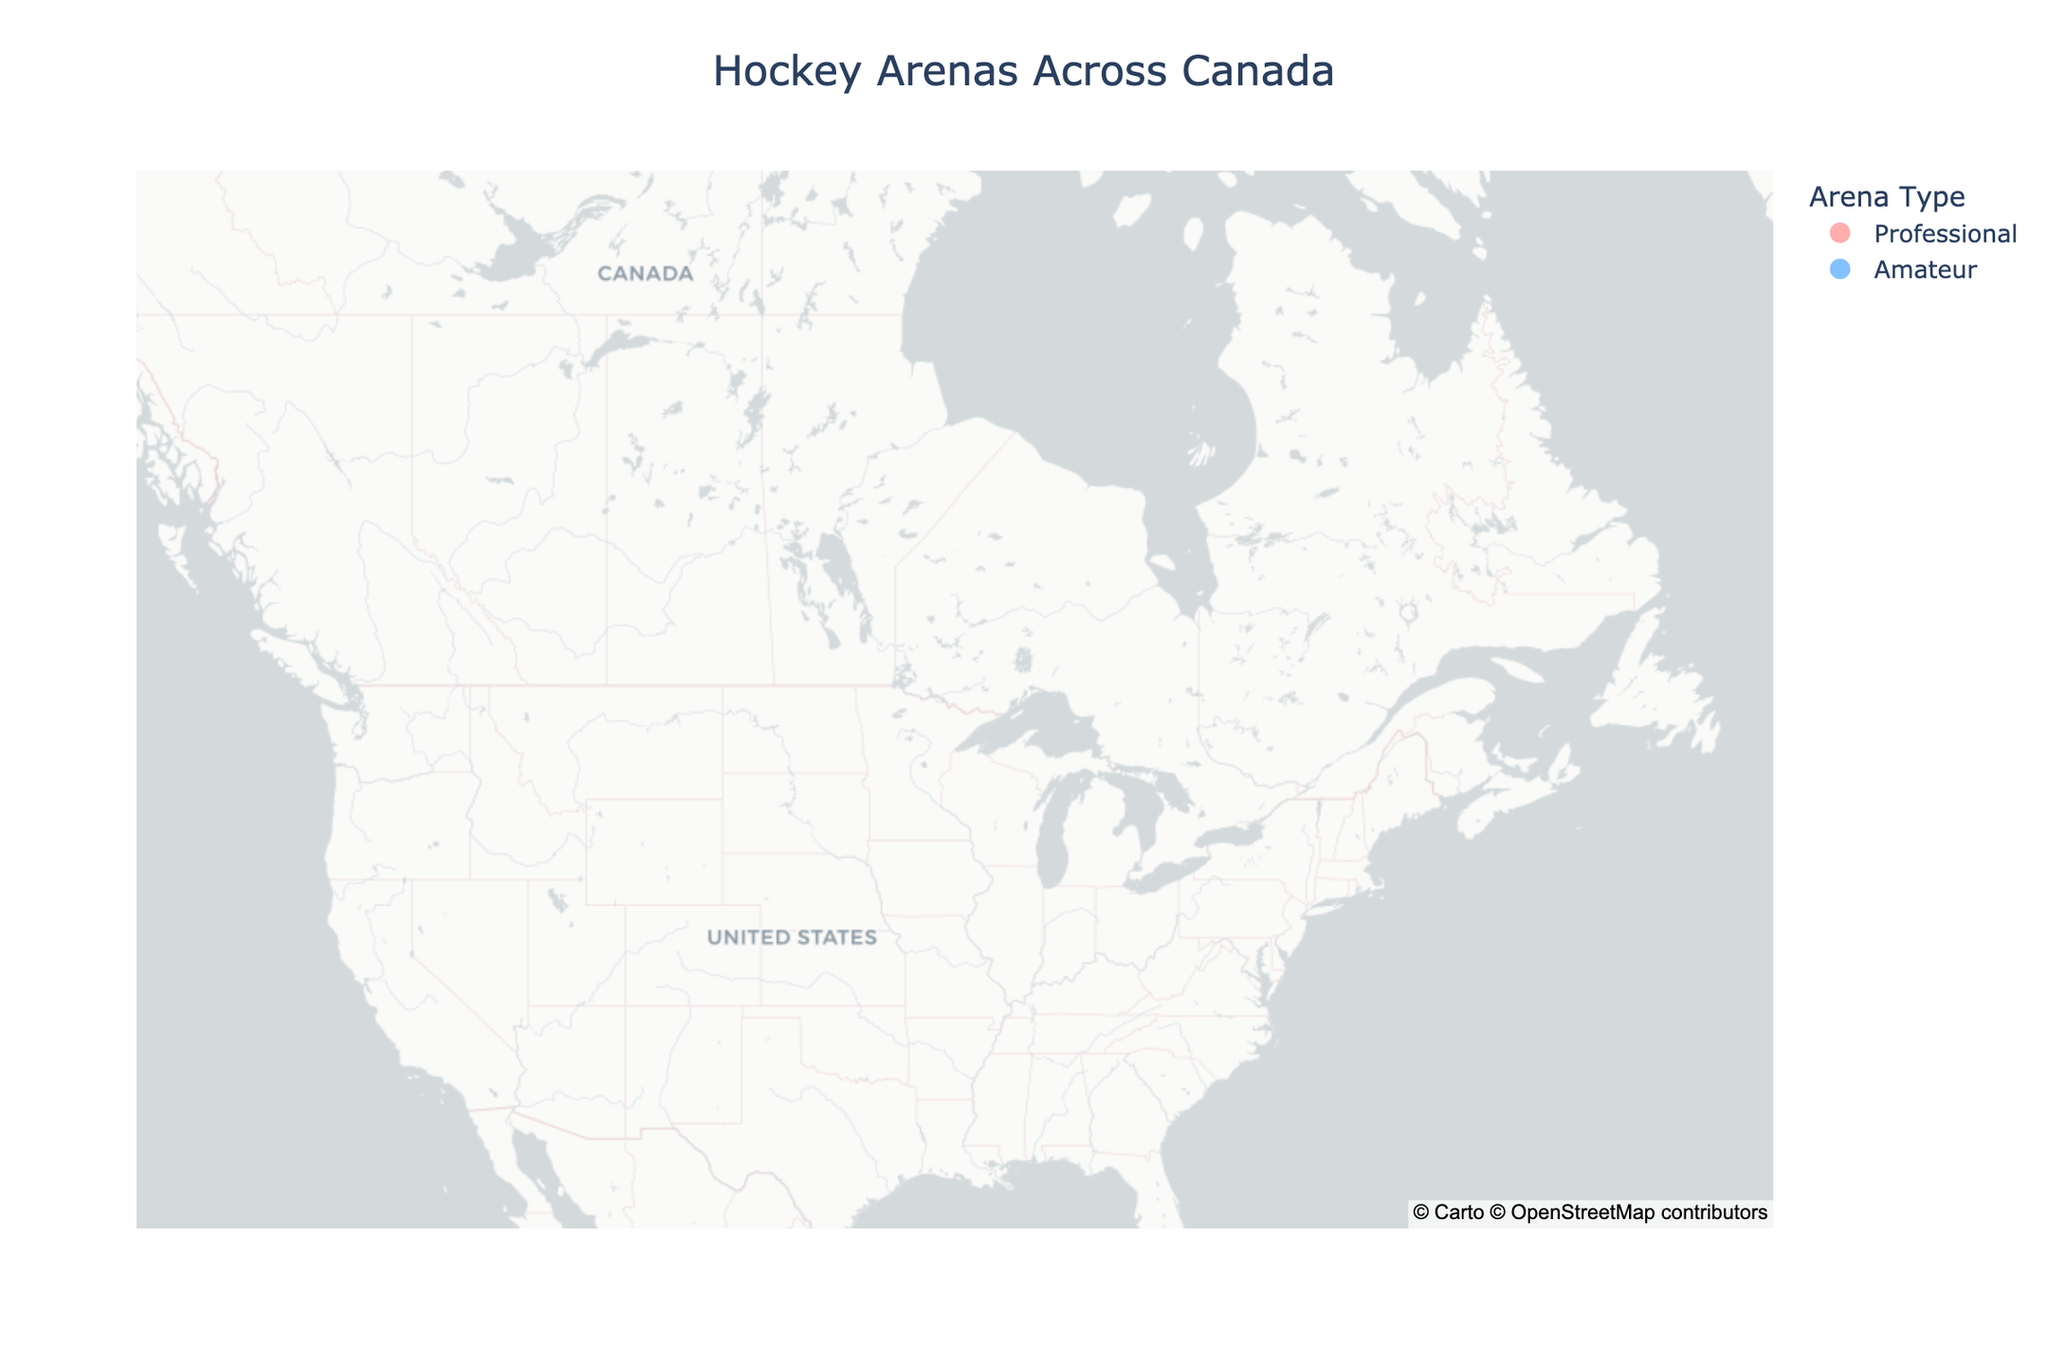Which city in Manitoba has an amateur hockey arena? By looking at Manitoba, we see that Brandon has an amateur arena named Westoba Place.
Answer: Brandon How many professional hockey arenas are in Ontario? By locating Ontario, we see there is one professional hockey arena, Scotiabank Arena in Toronto.
Answer: One Which province has both professional and amateur hockey arenas? By examining the provinces, Alberta is the one with both professional arena (Rogers Place in Edmonton) and amateur arena (Scotiabank Saddledome in Calgary).
Answer: Alberta Is there a professional hockey arena in Nova Scotia? By checking Nova Scotia, we see only an amateur arena, the Scotiabank Centre in Halifax, not a professional one.
Answer: No Which city has a hockey arena named Canada Life Centre? By inspecting the map, we see the Canada Life Centre is located in Winnipeg, Manitoba.
Answer: Winnipeg How many amateur hockey arenas are located in British Columbia? We spot British Columbia and find two amateur hockey arenas: Prospera Place in Kelowna and Sandman Centre in Kamloops.
Answer: Two Which province hosts the Scotiabank Arena? By identifying the Scotiabank Arena's location on the map, it's placed in Toronto, which is in Ontario.
Answer: Ontario Which cities have amateur facilities in Quebec? By reviewing Quebec, we recognize Sherbrooke has an amateur facility named Palais des Sports Léopold-Drolet while Montreal has the professional Bell Centre.
Answer: Sherbrooke Compare the number of hockey arenas in Alberta and Saskatchewan. Which has more? Alberta has two, one professional (Rogers Place) and one amateur (Scotiabank Saddledome), while Saskatchewan has two amateur arenas (Brandt Centre in Regina and SaskTel Centre in Saskatoon). Alberta and Saskatchewan both have two arenas.
Answer: Equal Which city has the northernmost professional hockey arena? By identifying the latitude, Edmonton (Rogers Place) is the northernmost professional arena.
Answer: Edmonton 